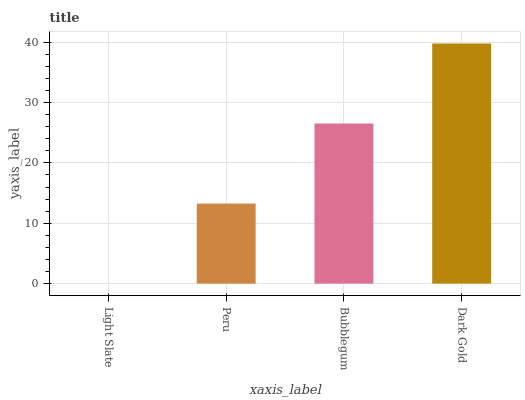Is Light Slate the minimum?
Answer yes or no. Yes. Is Dark Gold the maximum?
Answer yes or no. Yes. Is Peru the minimum?
Answer yes or no. No. Is Peru the maximum?
Answer yes or no. No. Is Peru greater than Light Slate?
Answer yes or no. Yes. Is Light Slate less than Peru?
Answer yes or no. Yes. Is Light Slate greater than Peru?
Answer yes or no. No. Is Peru less than Light Slate?
Answer yes or no. No. Is Bubblegum the high median?
Answer yes or no. Yes. Is Peru the low median?
Answer yes or no. Yes. Is Light Slate the high median?
Answer yes or no. No. Is Bubblegum the low median?
Answer yes or no. No. 